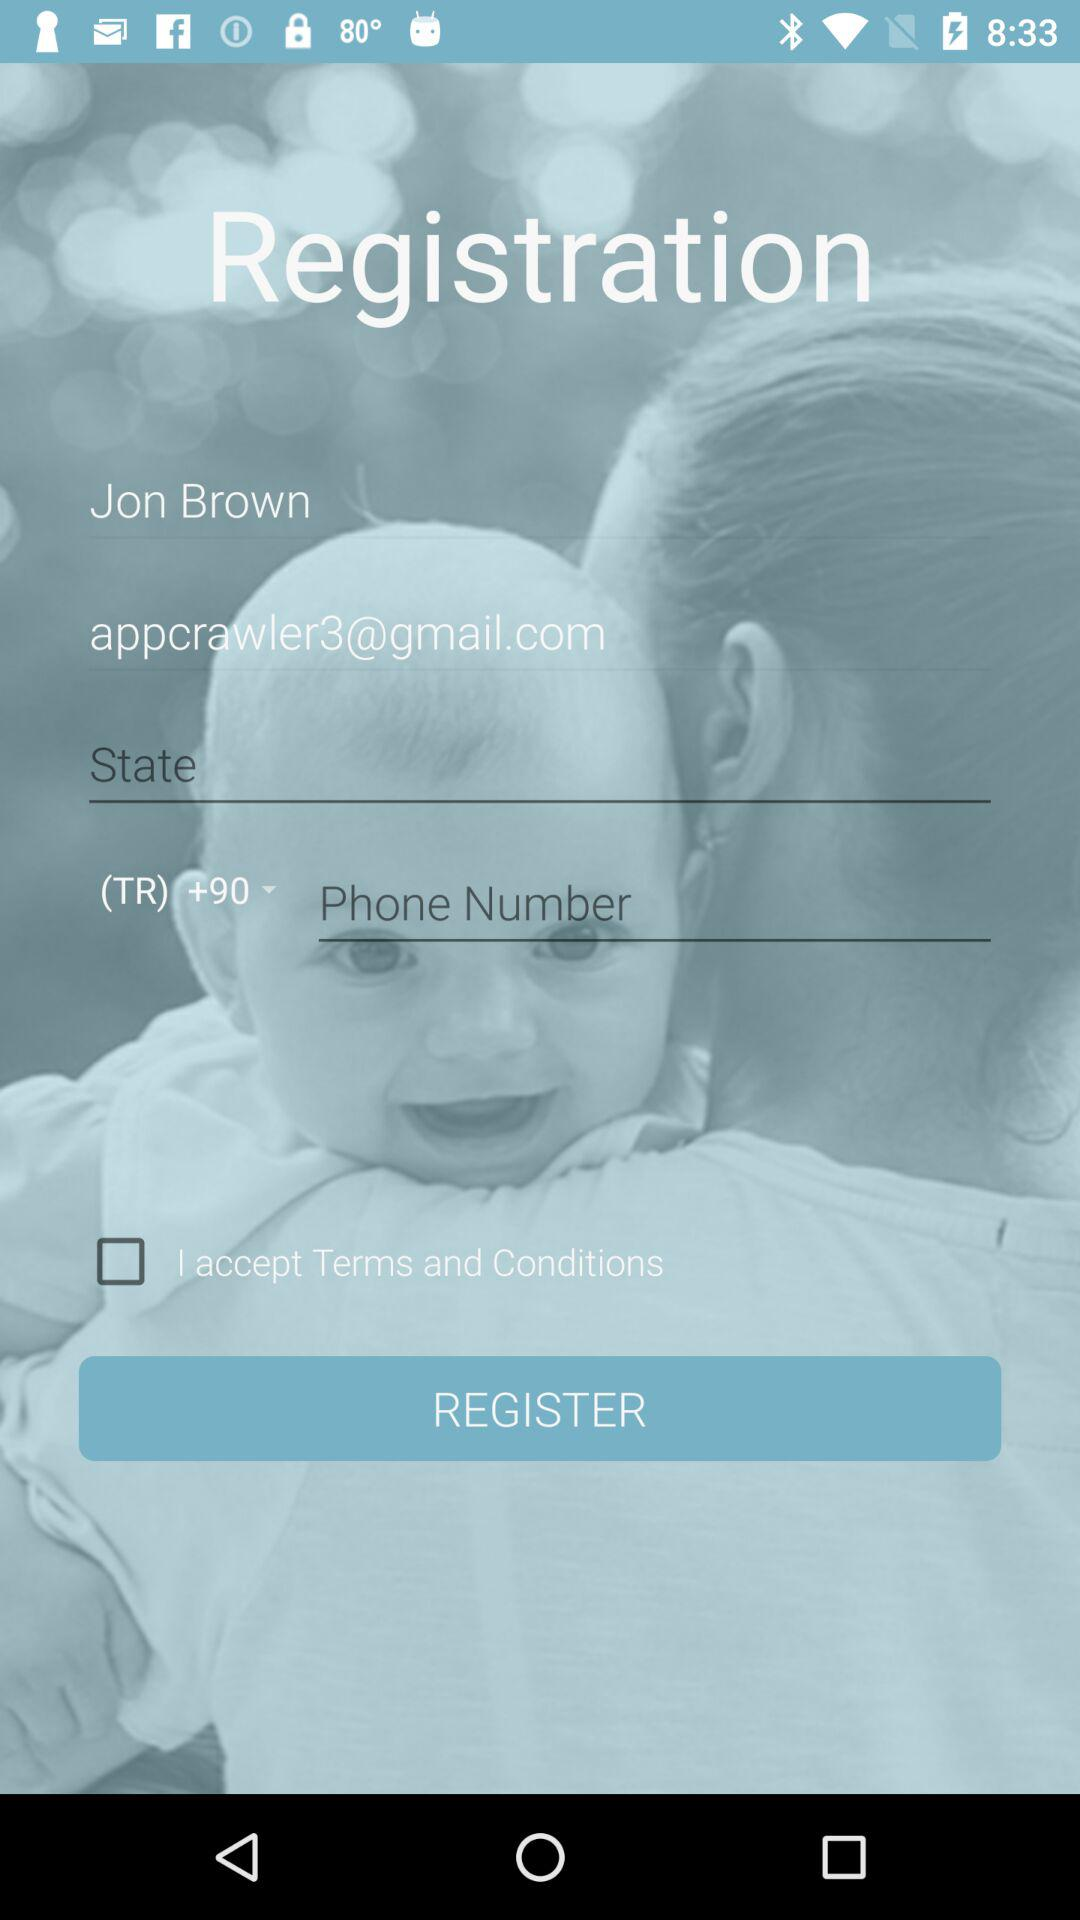What's the country code? The country code is +90. 